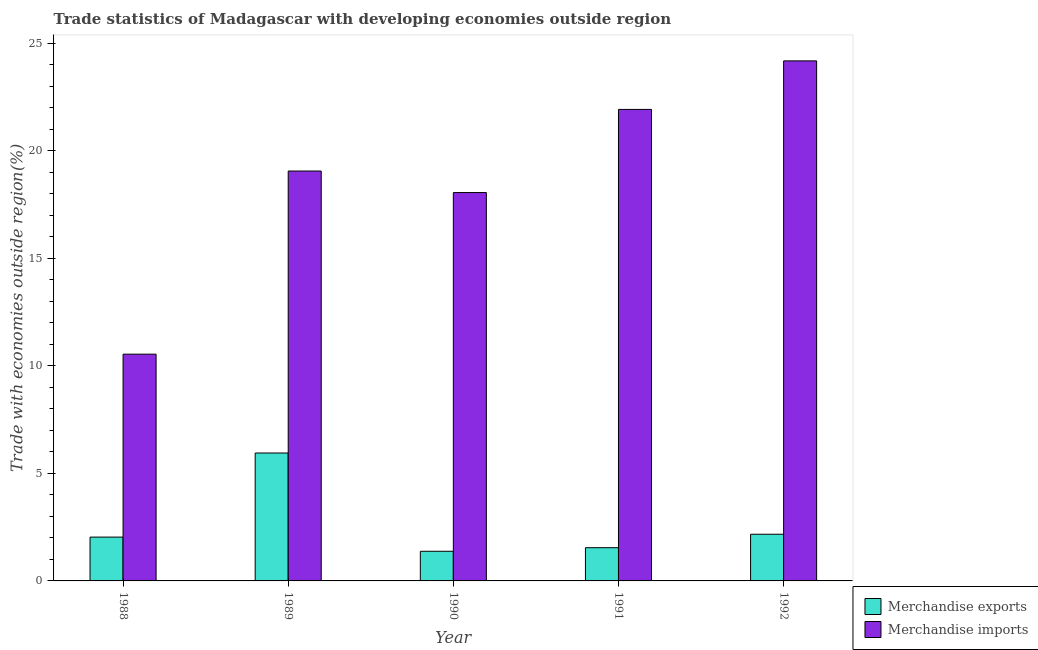How many bars are there on the 1st tick from the right?
Give a very brief answer. 2. What is the merchandise exports in 1988?
Your response must be concise. 2.04. Across all years, what is the maximum merchandise imports?
Offer a terse response. 24.19. Across all years, what is the minimum merchandise exports?
Offer a terse response. 1.38. In which year was the merchandise exports minimum?
Provide a succinct answer. 1990. What is the total merchandise imports in the graph?
Keep it short and to the point. 93.81. What is the difference between the merchandise imports in 1988 and that in 1991?
Offer a terse response. -11.39. What is the difference between the merchandise exports in 1988 and the merchandise imports in 1991?
Offer a terse response. 0.49. What is the average merchandise exports per year?
Offer a terse response. 2.62. What is the ratio of the merchandise imports in 1988 to that in 1991?
Keep it short and to the point. 0.48. What is the difference between the highest and the second highest merchandise exports?
Offer a very short reply. 3.78. What is the difference between the highest and the lowest merchandise imports?
Ensure brevity in your answer.  13.64. Is the sum of the merchandise exports in 1989 and 1992 greater than the maximum merchandise imports across all years?
Your answer should be very brief. Yes. What does the 2nd bar from the left in 1990 represents?
Your response must be concise. Merchandise imports. What does the 2nd bar from the right in 1991 represents?
Your response must be concise. Merchandise exports. Are all the bars in the graph horizontal?
Your response must be concise. No. How many years are there in the graph?
Your response must be concise. 5. What is the difference between two consecutive major ticks on the Y-axis?
Offer a terse response. 5. Does the graph contain grids?
Your response must be concise. No. How many legend labels are there?
Offer a very short reply. 2. What is the title of the graph?
Offer a terse response. Trade statistics of Madagascar with developing economies outside region. What is the label or title of the X-axis?
Ensure brevity in your answer.  Year. What is the label or title of the Y-axis?
Ensure brevity in your answer.  Trade with economies outside region(%). What is the Trade with economies outside region(%) of Merchandise exports in 1988?
Your response must be concise. 2.04. What is the Trade with economies outside region(%) in Merchandise imports in 1988?
Offer a terse response. 10.55. What is the Trade with economies outside region(%) of Merchandise exports in 1989?
Offer a terse response. 5.95. What is the Trade with economies outside region(%) of Merchandise imports in 1989?
Your answer should be compact. 19.07. What is the Trade with economies outside region(%) of Merchandise exports in 1990?
Give a very brief answer. 1.38. What is the Trade with economies outside region(%) of Merchandise imports in 1990?
Provide a succinct answer. 18.07. What is the Trade with economies outside region(%) of Merchandise exports in 1991?
Your response must be concise. 1.55. What is the Trade with economies outside region(%) in Merchandise imports in 1991?
Your answer should be compact. 21.93. What is the Trade with economies outside region(%) in Merchandise exports in 1992?
Make the answer very short. 2.17. What is the Trade with economies outside region(%) of Merchandise imports in 1992?
Your answer should be compact. 24.19. Across all years, what is the maximum Trade with economies outside region(%) of Merchandise exports?
Provide a succinct answer. 5.95. Across all years, what is the maximum Trade with economies outside region(%) of Merchandise imports?
Your answer should be compact. 24.19. Across all years, what is the minimum Trade with economies outside region(%) in Merchandise exports?
Make the answer very short. 1.38. Across all years, what is the minimum Trade with economies outside region(%) of Merchandise imports?
Provide a short and direct response. 10.55. What is the total Trade with economies outside region(%) in Merchandise exports in the graph?
Make the answer very short. 13.08. What is the total Trade with economies outside region(%) in Merchandise imports in the graph?
Keep it short and to the point. 93.81. What is the difference between the Trade with economies outside region(%) of Merchandise exports in 1988 and that in 1989?
Keep it short and to the point. -3.91. What is the difference between the Trade with economies outside region(%) of Merchandise imports in 1988 and that in 1989?
Your response must be concise. -8.52. What is the difference between the Trade with economies outside region(%) of Merchandise exports in 1988 and that in 1990?
Provide a succinct answer. 0.66. What is the difference between the Trade with economies outside region(%) in Merchandise imports in 1988 and that in 1990?
Keep it short and to the point. -7.52. What is the difference between the Trade with economies outside region(%) in Merchandise exports in 1988 and that in 1991?
Your response must be concise. 0.49. What is the difference between the Trade with economies outside region(%) of Merchandise imports in 1988 and that in 1991?
Give a very brief answer. -11.39. What is the difference between the Trade with economies outside region(%) in Merchandise exports in 1988 and that in 1992?
Offer a very short reply. -0.13. What is the difference between the Trade with economies outside region(%) in Merchandise imports in 1988 and that in 1992?
Make the answer very short. -13.64. What is the difference between the Trade with economies outside region(%) of Merchandise exports in 1989 and that in 1990?
Keep it short and to the point. 4.57. What is the difference between the Trade with economies outside region(%) in Merchandise imports in 1989 and that in 1990?
Your response must be concise. 1. What is the difference between the Trade with economies outside region(%) in Merchandise exports in 1989 and that in 1991?
Make the answer very short. 4.4. What is the difference between the Trade with economies outside region(%) of Merchandise imports in 1989 and that in 1991?
Offer a terse response. -2.87. What is the difference between the Trade with economies outside region(%) in Merchandise exports in 1989 and that in 1992?
Your response must be concise. 3.78. What is the difference between the Trade with economies outside region(%) of Merchandise imports in 1989 and that in 1992?
Provide a succinct answer. -5.12. What is the difference between the Trade with economies outside region(%) in Merchandise exports in 1990 and that in 1991?
Offer a terse response. -0.17. What is the difference between the Trade with economies outside region(%) in Merchandise imports in 1990 and that in 1991?
Offer a very short reply. -3.87. What is the difference between the Trade with economies outside region(%) in Merchandise exports in 1990 and that in 1992?
Provide a succinct answer. -0.79. What is the difference between the Trade with economies outside region(%) of Merchandise imports in 1990 and that in 1992?
Provide a short and direct response. -6.13. What is the difference between the Trade with economies outside region(%) in Merchandise exports in 1991 and that in 1992?
Provide a succinct answer. -0.63. What is the difference between the Trade with economies outside region(%) in Merchandise imports in 1991 and that in 1992?
Your response must be concise. -2.26. What is the difference between the Trade with economies outside region(%) in Merchandise exports in 1988 and the Trade with economies outside region(%) in Merchandise imports in 1989?
Make the answer very short. -17.03. What is the difference between the Trade with economies outside region(%) of Merchandise exports in 1988 and the Trade with economies outside region(%) of Merchandise imports in 1990?
Your response must be concise. -16.03. What is the difference between the Trade with economies outside region(%) of Merchandise exports in 1988 and the Trade with economies outside region(%) of Merchandise imports in 1991?
Your response must be concise. -19.9. What is the difference between the Trade with economies outside region(%) in Merchandise exports in 1988 and the Trade with economies outside region(%) in Merchandise imports in 1992?
Offer a terse response. -22.15. What is the difference between the Trade with economies outside region(%) of Merchandise exports in 1989 and the Trade with economies outside region(%) of Merchandise imports in 1990?
Make the answer very short. -12.12. What is the difference between the Trade with economies outside region(%) in Merchandise exports in 1989 and the Trade with economies outside region(%) in Merchandise imports in 1991?
Provide a short and direct response. -15.98. What is the difference between the Trade with economies outside region(%) in Merchandise exports in 1989 and the Trade with economies outside region(%) in Merchandise imports in 1992?
Offer a terse response. -18.24. What is the difference between the Trade with economies outside region(%) in Merchandise exports in 1990 and the Trade with economies outside region(%) in Merchandise imports in 1991?
Offer a very short reply. -20.55. What is the difference between the Trade with economies outside region(%) in Merchandise exports in 1990 and the Trade with economies outside region(%) in Merchandise imports in 1992?
Offer a very short reply. -22.81. What is the difference between the Trade with economies outside region(%) of Merchandise exports in 1991 and the Trade with economies outside region(%) of Merchandise imports in 1992?
Offer a very short reply. -22.65. What is the average Trade with economies outside region(%) in Merchandise exports per year?
Give a very brief answer. 2.62. What is the average Trade with economies outside region(%) in Merchandise imports per year?
Your response must be concise. 18.76. In the year 1988, what is the difference between the Trade with economies outside region(%) in Merchandise exports and Trade with economies outside region(%) in Merchandise imports?
Your answer should be compact. -8.51. In the year 1989, what is the difference between the Trade with economies outside region(%) in Merchandise exports and Trade with economies outside region(%) in Merchandise imports?
Ensure brevity in your answer.  -13.12. In the year 1990, what is the difference between the Trade with economies outside region(%) in Merchandise exports and Trade with economies outside region(%) in Merchandise imports?
Your response must be concise. -16.69. In the year 1991, what is the difference between the Trade with economies outside region(%) in Merchandise exports and Trade with economies outside region(%) in Merchandise imports?
Offer a very short reply. -20.39. In the year 1992, what is the difference between the Trade with economies outside region(%) of Merchandise exports and Trade with economies outside region(%) of Merchandise imports?
Make the answer very short. -22.02. What is the ratio of the Trade with economies outside region(%) of Merchandise exports in 1988 to that in 1989?
Ensure brevity in your answer.  0.34. What is the ratio of the Trade with economies outside region(%) of Merchandise imports in 1988 to that in 1989?
Your answer should be very brief. 0.55. What is the ratio of the Trade with economies outside region(%) of Merchandise exports in 1988 to that in 1990?
Your answer should be compact. 1.48. What is the ratio of the Trade with economies outside region(%) in Merchandise imports in 1988 to that in 1990?
Your answer should be very brief. 0.58. What is the ratio of the Trade with economies outside region(%) in Merchandise exports in 1988 to that in 1991?
Offer a terse response. 1.32. What is the ratio of the Trade with economies outside region(%) in Merchandise imports in 1988 to that in 1991?
Ensure brevity in your answer.  0.48. What is the ratio of the Trade with economies outside region(%) in Merchandise exports in 1988 to that in 1992?
Keep it short and to the point. 0.94. What is the ratio of the Trade with economies outside region(%) in Merchandise imports in 1988 to that in 1992?
Offer a very short reply. 0.44. What is the ratio of the Trade with economies outside region(%) in Merchandise exports in 1989 to that in 1990?
Provide a succinct answer. 4.31. What is the ratio of the Trade with economies outside region(%) of Merchandise imports in 1989 to that in 1990?
Your answer should be compact. 1.06. What is the ratio of the Trade with economies outside region(%) in Merchandise exports in 1989 to that in 1991?
Your answer should be compact. 3.85. What is the ratio of the Trade with economies outside region(%) of Merchandise imports in 1989 to that in 1991?
Provide a short and direct response. 0.87. What is the ratio of the Trade with economies outside region(%) of Merchandise exports in 1989 to that in 1992?
Offer a terse response. 2.74. What is the ratio of the Trade with economies outside region(%) of Merchandise imports in 1989 to that in 1992?
Your answer should be compact. 0.79. What is the ratio of the Trade with economies outside region(%) in Merchandise exports in 1990 to that in 1991?
Keep it short and to the point. 0.89. What is the ratio of the Trade with economies outside region(%) in Merchandise imports in 1990 to that in 1991?
Offer a terse response. 0.82. What is the ratio of the Trade with economies outside region(%) in Merchandise exports in 1990 to that in 1992?
Give a very brief answer. 0.64. What is the ratio of the Trade with economies outside region(%) in Merchandise imports in 1990 to that in 1992?
Ensure brevity in your answer.  0.75. What is the ratio of the Trade with economies outside region(%) in Merchandise exports in 1991 to that in 1992?
Your answer should be compact. 0.71. What is the ratio of the Trade with economies outside region(%) of Merchandise imports in 1991 to that in 1992?
Give a very brief answer. 0.91. What is the difference between the highest and the second highest Trade with economies outside region(%) in Merchandise exports?
Provide a short and direct response. 3.78. What is the difference between the highest and the second highest Trade with economies outside region(%) in Merchandise imports?
Give a very brief answer. 2.26. What is the difference between the highest and the lowest Trade with economies outside region(%) in Merchandise exports?
Ensure brevity in your answer.  4.57. What is the difference between the highest and the lowest Trade with economies outside region(%) of Merchandise imports?
Your answer should be compact. 13.64. 